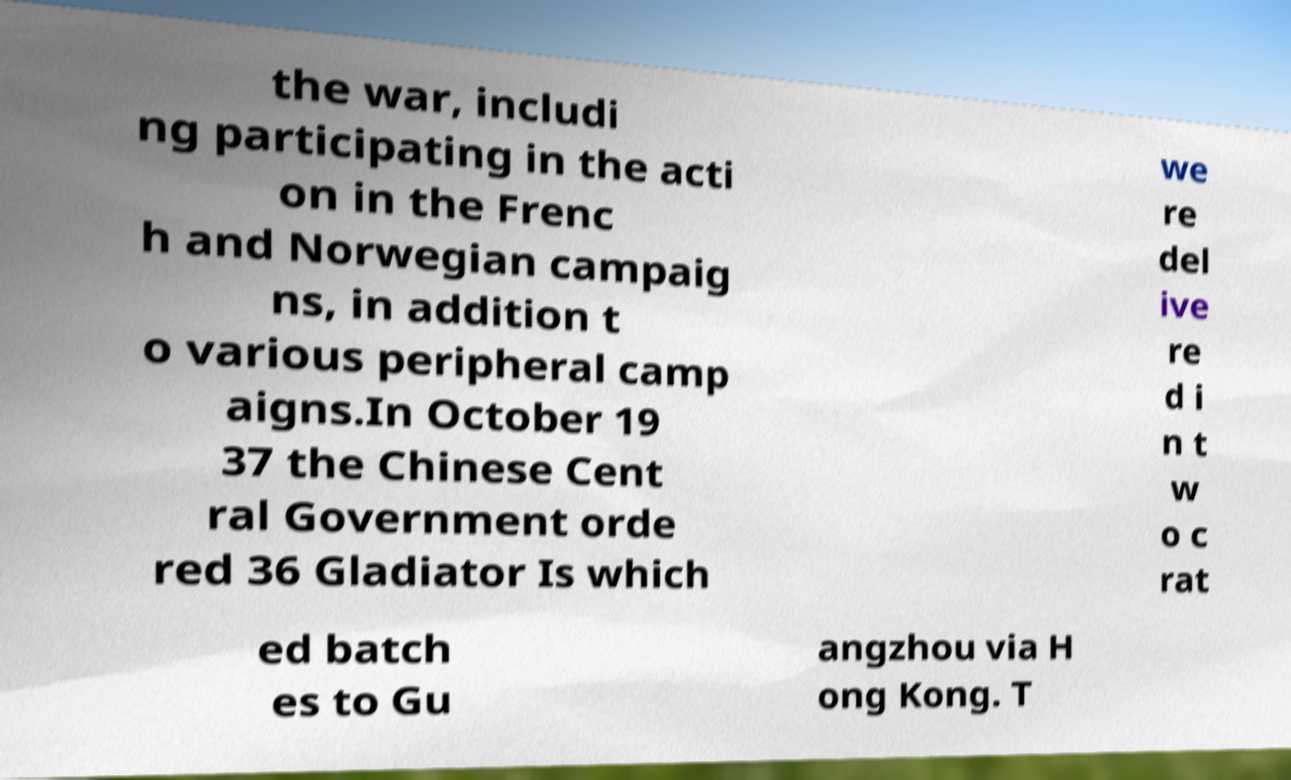What messages or text are displayed in this image? I need them in a readable, typed format. the war, includi ng participating in the acti on in the Frenc h and Norwegian campaig ns, in addition t o various peripheral camp aigns.In October 19 37 the Chinese Cent ral Government orde red 36 Gladiator Is which we re del ive re d i n t w o c rat ed batch es to Gu angzhou via H ong Kong. T 